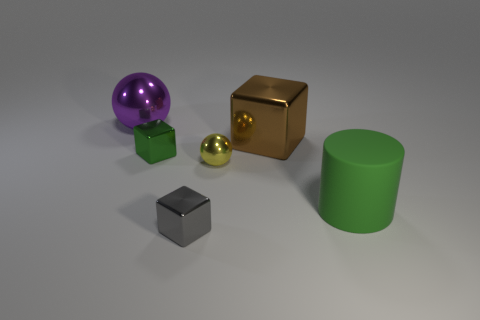Subtract all big brown metal blocks. How many blocks are left? 2 Subtract 1 cubes. How many cubes are left? 2 Subtract all spheres. How many objects are left? 4 Subtract all yellow spheres. How many spheres are left? 1 Subtract all green cubes. Subtract all brown cylinders. How many cubes are left? 2 Subtract all purple cylinders. How many purple balls are left? 1 Subtract all big shiny objects. Subtract all yellow metal balls. How many objects are left? 3 Add 4 yellow shiny objects. How many yellow shiny objects are left? 5 Add 1 small purple rubber objects. How many small purple rubber objects exist? 1 Add 1 tiny green cubes. How many objects exist? 7 